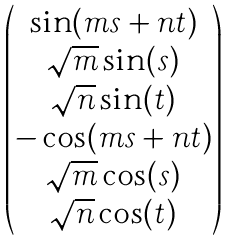Convert formula to latex. <formula><loc_0><loc_0><loc_500><loc_500>\begin{pmatrix} \sin ( m s + n t ) \\ \sqrt { m } \sin ( s ) \\ \sqrt { n } \sin ( t ) \\ - \cos ( m s + n t ) \\ \sqrt { m } \cos ( s ) \\ \sqrt { n } \cos ( t ) \end{pmatrix}</formula> 